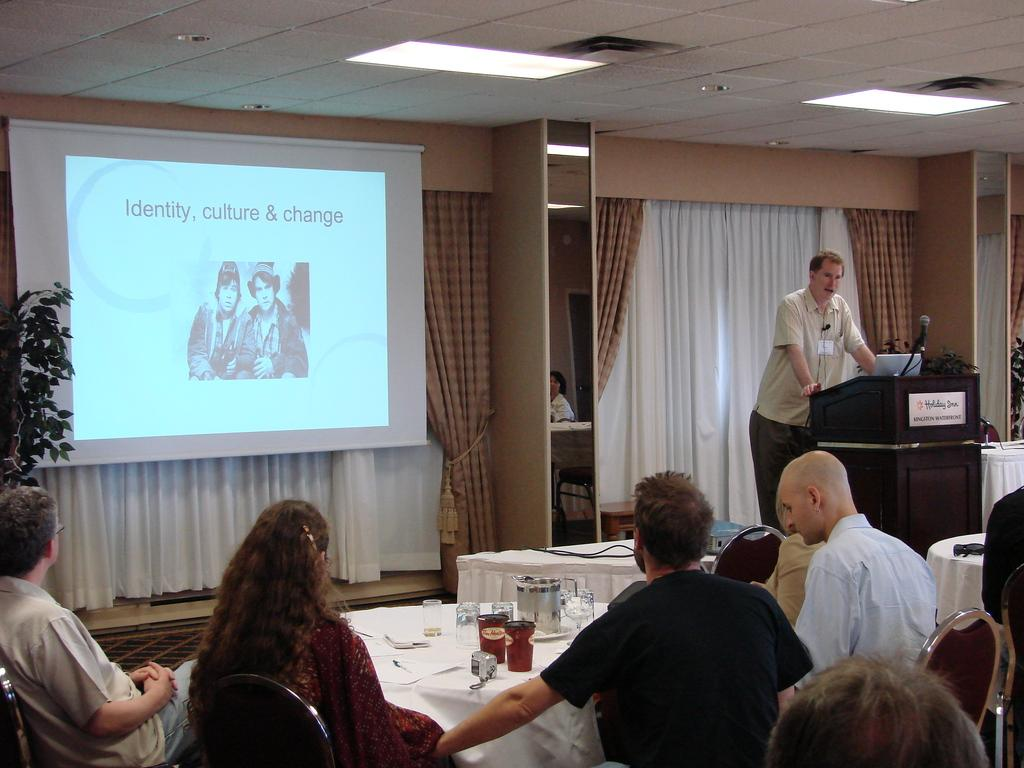<image>
Create a compact narrative representing the image presented. A man is speaking about "identity, culture & change". 